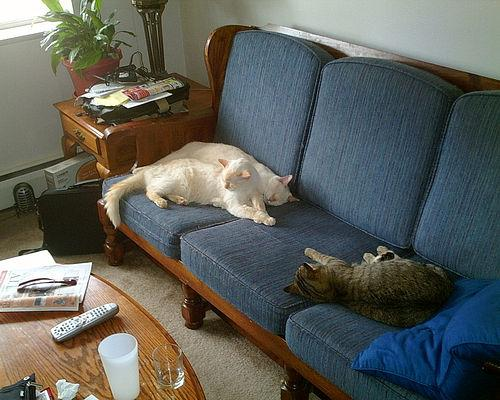What is the silver object on the table in front of the couch used to control?

Choices:
A) lights
B) garage door
C) fan
D) tv tv 